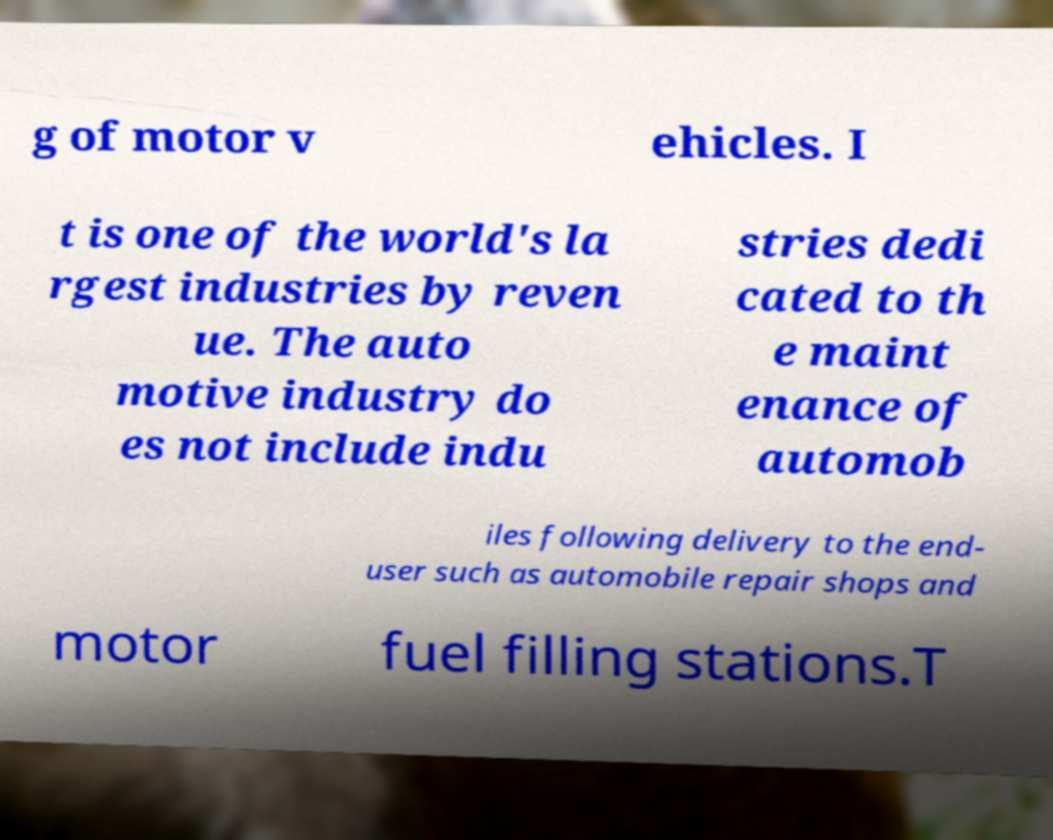There's text embedded in this image that I need extracted. Can you transcribe it verbatim? g of motor v ehicles. I t is one of the world's la rgest industries by reven ue. The auto motive industry do es not include indu stries dedi cated to th e maint enance of automob iles following delivery to the end- user such as automobile repair shops and motor fuel filling stations.T 